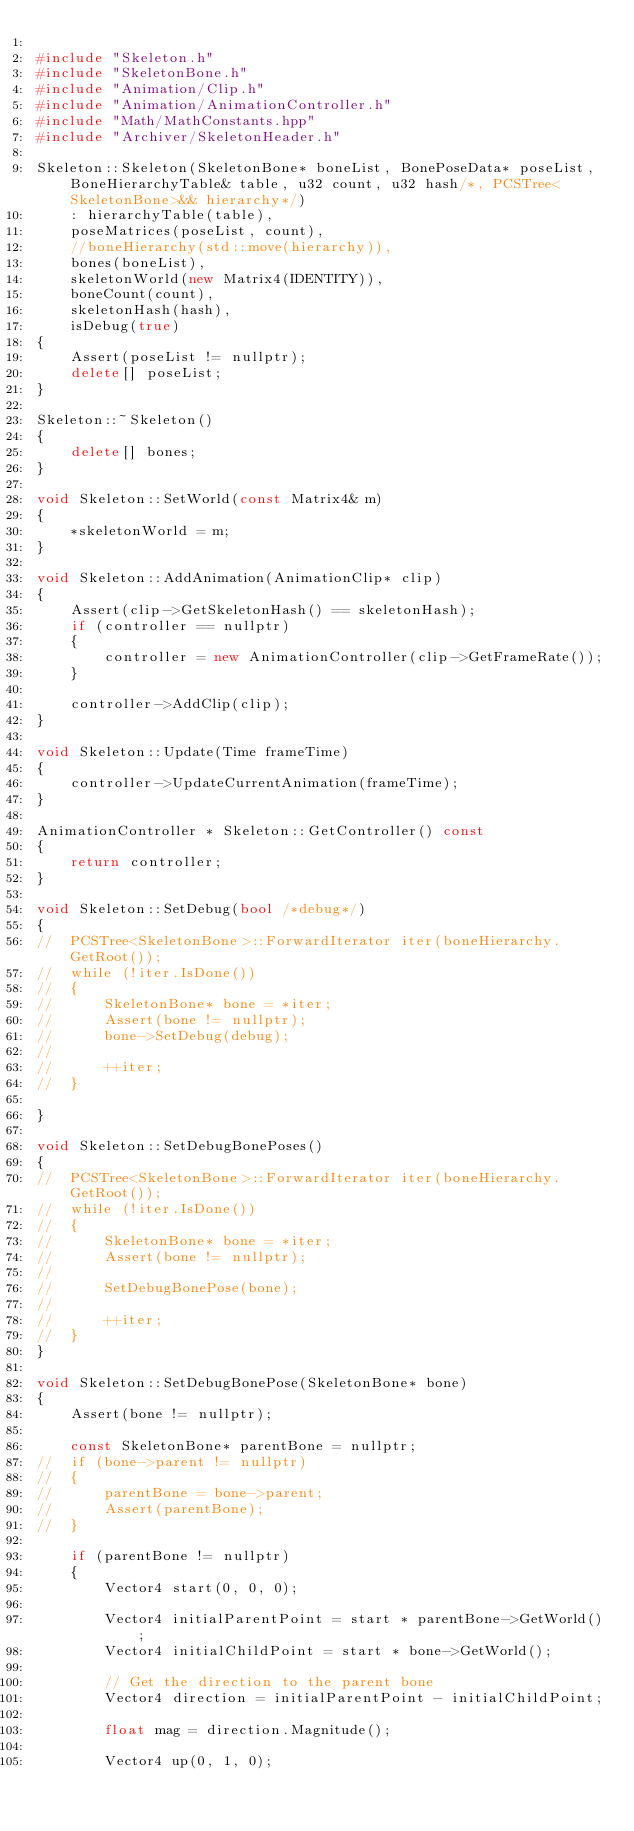<code> <loc_0><loc_0><loc_500><loc_500><_C++_>
#include "Skeleton.h"
#include "SkeletonBone.h"
#include "Animation/Clip.h"
#include "Animation/AnimationController.h"
#include "Math/MathConstants.hpp"
#include "Archiver/SkeletonHeader.h"

Skeleton::Skeleton(SkeletonBone* boneList, BonePoseData* poseList, BoneHierarchyTable& table, u32 count, u32 hash/*, PCSTree<SkeletonBone>&& hierarchy*/)
	: hierarchyTable(table),
	poseMatrices(poseList, count),
	//boneHierarchy(std::move(hierarchy)),
	bones(boneList),
	skeletonWorld(new Matrix4(IDENTITY)),
	boneCount(count),
	skeletonHash(hash),
	isDebug(true)
{
	Assert(poseList != nullptr);
	delete[] poseList;
}

Skeleton::~Skeleton()
{
	delete[] bones;
}

void Skeleton::SetWorld(const Matrix4& m)
{
	*skeletonWorld = m;
}

void Skeleton::AddAnimation(AnimationClip* clip)
{
	Assert(clip->GetSkeletonHash() == skeletonHash);
	if (controller == nullptr)
	{
		controller = new AnimationController(clip->GetFrameRate());
	}

	controller->AddClip(clip);
}

void Skeleton::Update(Time frameTime)
{
	controller->UpdateCurrentAnimation(frameTime);
}

AnimationController * Skeleton::GetController() const
{
	return controller;
}

void Skeleton::SetDebug(bool /*debug*/)
{
// 	PCSTree<SkeletonBone>::ForwardIterator iter(boneHierarchy.GetRoot());
// 	while (!iter.IsDone())
// 	{
// 		SkeletonBone* bone = *iter;
// 		Assert(bone != nullptr);
// 		bone->SetDebug(debug);
// 
// 		++iter;
// 	}

}

void Skeleton::SetDebugBonePoses()
{
// 	PCSTree<SkeletonBone>::ForwardIterator iter(boneHierarchy.GetRoot());
// 	while (!iter.IsDone())
// 	{
// 		SkeletonBone* bone = *iter;
// 		Assert(bone != nullptr);
// 		
// 		SetDebugBonePose(bone);
// 
// 		++iter;
// 	}
}

void Skeleton::SetDebugBonePose(SkeletonBone* bone)
{
	Assert(bone != nullptr);

	const SkeletonBone* parentBone = nullptr;
// 	if (bone->parent != nullptr)
// 	{
// 		parentBone = bone->parent;
// 		Assert(parentBone);
// 	}

	if (parentBone != nullptr)
	{
		Vector4 start(0, 0, 0);

		Vector4 initialParentPoint = start * parentBone->GetWorld();
		Vector4 initialChildPoint = start * bone->GetWorld();

		// Get the direction to the parent bone
		Vector4 direction = initialParentPoint - initialChildPoint;

		float mag = direction.Magnitude();

		Vector4 up(0, 1, 0);</code> 